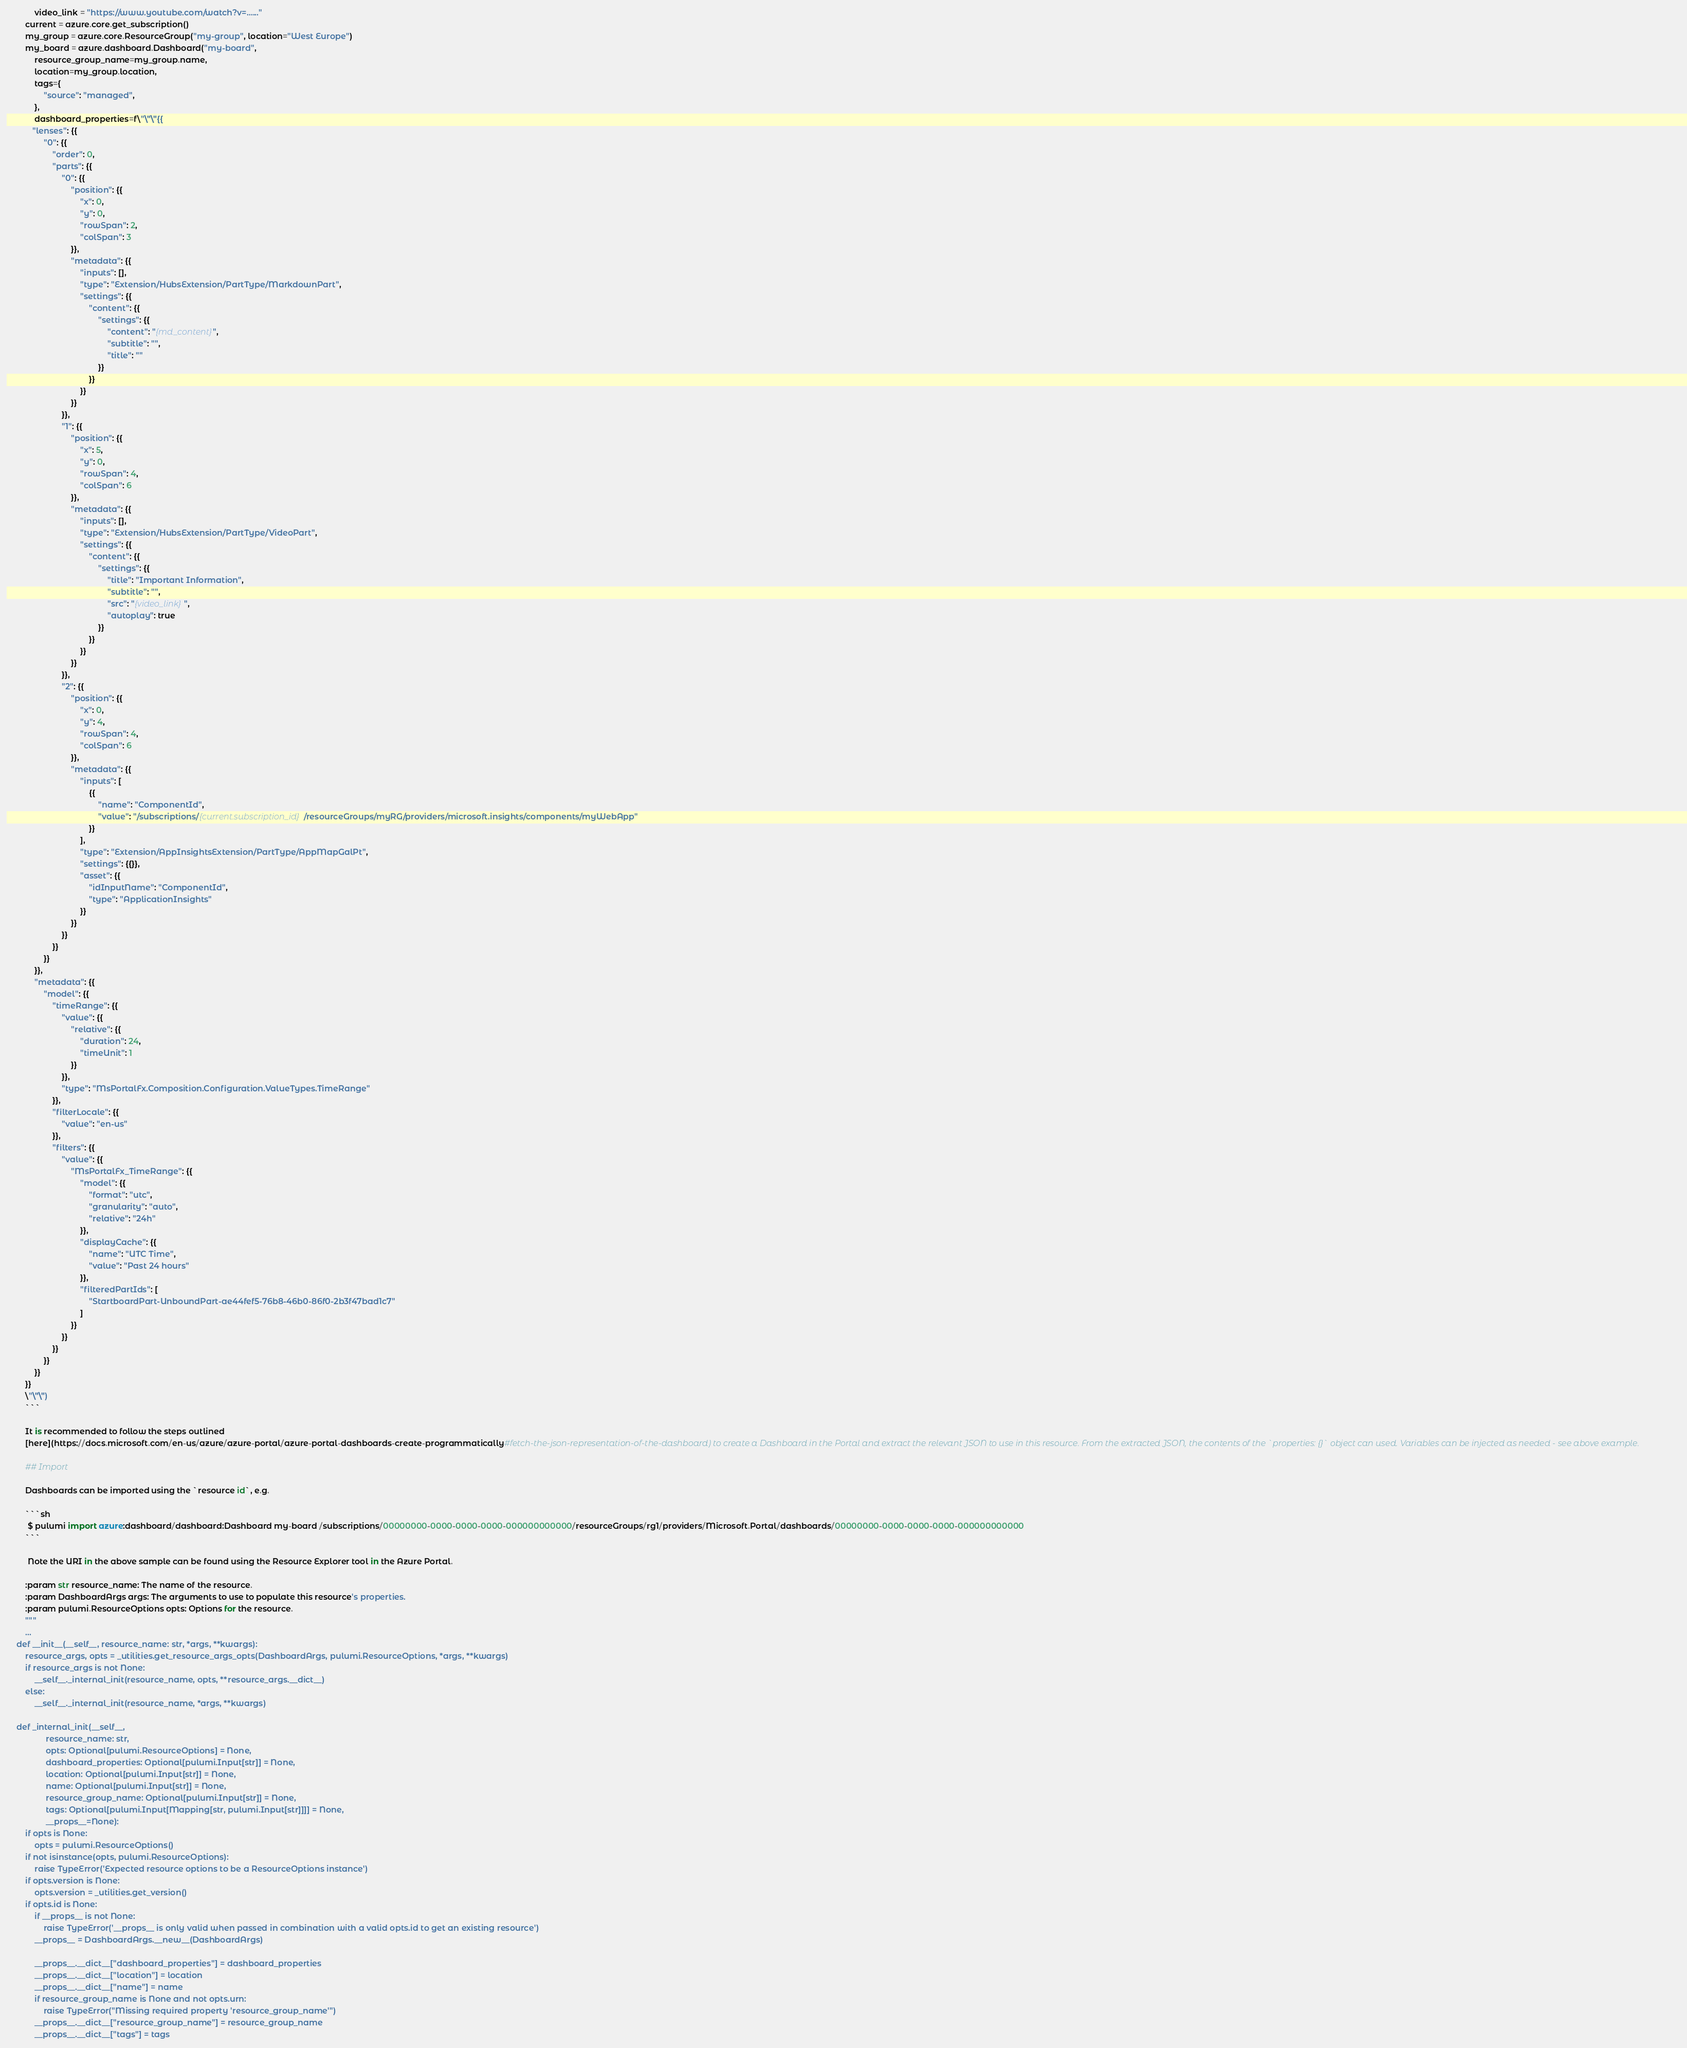Convert code to text. <code><loc_0><loc_0><loc_500><loc_500><_Python_>            video_link = "https://www.youtube.com/watch?v=......"
        current = azure.core.get_subscription()
        my_group = azure.core.ResourceGroup("my-group", location="West Europe")
        my_board = azure.dashboard.Dashboard("my-board",
            resource_group_name=my_group.name,
            location=my_group.location,
            tags={
                "source": "managed",
            },
            dashboard_properties=f\"\"\"{{
           "lenses": {{
                "0": {{
                    "order": 0,
                    "parts": {{
                        "0": {{
                            "position": {{
                                "x": 0,
                                "y": 0,
                                "rowSpan": 2,
                                "colSpan": 3
                            }},
                            "metadata": {{
                                "inputs": [],
                                "type": "Extension/HubsExtension/PartType/MarkdownPart",
                                "settings": {{
                                    "content": {{
                                        "settings": {{
                                            "content": "{md_content}",
                                            "subtitle": "",
                                            "title": ""
                                        }}
                                    }}
                                }}
                            }}
                        }},               
                        "1": {{
                            "position": {{
                                "x": 5,
                                "y": 0,
                                "rowSpan": 4,
                                "colSpan": 6
                            }},
                            "metadata": {{
                                "inputs": [],
                                "type": "Extension/HubsExtension/PartType/VideoPart",
                                "settings": {{
                                    "content": {{
                                        "settings": {{
                                            "title": "Important Information",
                                            "subtitle": "",
                                            "src": "{video_link}",
                                            "autoplay": true
                                        }}
                                    }}
                                }}
                            }}
                        }},
                        "2": {{
                            "position": {{
                                "x": 0,
                                "y": 4,
                                "rowSpan": 4,
                                "colSpan": 6
                            }},
                            "metadata": {{
                                "inputs": [
                                    {{
                                        "name": "ComponentId",
                                        "value": "/subscriptions/{current.subscription_id}/resourceGroups/myRG/providers/microsoft.insights/components/myWebApp"
                                    }}
                                ],
                                "type": "Extension/AppInsightsExtension/PartType/AppMapGalPt",
                                "settings": {{}},
                                "asset": {{
                                    "idInputName": "ComponentId",
                                    "type": "ApplicationInsights"
                                }}
                            }}
                        }}              
                    }}
                }}
            }},
            "metadata": {{
                "model": {{
                    "timeRange": {{
                        "value": {{
                            "relative": {{
                                "duration": 24,
                                "timeUnit": 1
                            }}
                        }},
                        "type": "MsPortalFx.Composition.Configuration.ValueTypes.TimeRange"
                    }},
                    "filterLocale": {{
                        "value": "en-us"
                    }},
                    "filters": {{
                        "value": {{
                            "MsPortalFx_TimeRange": {{
                                "model": {{
                                    "format": "utc",
                                    "granularity": "auto",
                                    "relative": "24h"
                                }},
                                "displayCache": {{
                                    "name": "UTC Time",
                                    "value": "Past 24 hours"
                                }},
                                "filteredPartIds": [
                                    "StartboardPart-UnboundPart-ae44fef5-76b8-46b0-86f0-2b3f47bad1c7"
                                ]
                            }}
                        }}
                    }}
                }}
            }}
        }}
        \"\"\")
        ```

        It is recommended to follow the steps outlined
        [here](https://docs.microsoft.com/en-us/azure/azure-portal/azure-portal-dashboards-create-programmatically#fetch-the-json-representation-of-the-dashboard) to create a Dashboard in the Portal and extract the relevant JSON to use in this resource. From the extracted JSON, the contents of the `properties: {}` object can used. Variables can be injected as needed - see above example.

        ## Import

        Dashboards can be imported using the `resource id`, e.g.

        ```sh
         $ pulumi import azure:dashboard/dashboard:Dashboard my-board /subscriptions/00000000-0000-0000-0000-000000000000/resourceGroups/rg1/providers/Microsoft.Portal/dashboards/00000000-0000-0000-0000-000000000000
        ```

         Note the URI in the above sample can be found using the Resource Explorer tool in the Azure Portal.

        :param str resource_name: The name of the resource.
        :param DashboardArgs args: The arguments to use to populate this resource's properties.
        :param pulumi.ResourceOptions opts: Options for the resource.
        """
        ...
    def __init__(__self__, resource_name: str, *args, **kwargs):
        resource_args, opts = _utilities.get_resource_args_opts(DashboardArgs, pulumi.ResourceOptions, *args, **kwargs)
        if resource_args is not None:
            __self__._internal_init(resource_name, opts, **resource_args.__dict__)
        else:
            __self__._internal_init(resource_name, *args, **kwargs)

    def _internal_init(__self__,
                 resource_name: str,
                 opts: Optional[pulumi.ResourceOptions] = None,
                 dashboard_properties: Optional[pulumi.Input[str]] = None,
                 location: Optional[pulumi.Input[str]] = None,
                 name: Optional[pulumi.Input[str]] = None,
                 resource_group_name: Optional[pulumi.Input[str]] = None,
                 tags: Optional[pulumi.Input[Mapping[str, pulumi.Input[str]]]] = None,
                 __props__=None):
        if opts is None:
            opts = pulumi.ResourceOptions()
        if not isinstance(opts, pulumi.ResourceOptions):
            raise TypeError('Expected resource options to be a ResourceOptions instance')
        if opts.version is None:
            opts.version = _utilities.get_version()
        if opts.id is None:
            if __props__ is not None:
                raise TypeError('__props__ is only valid when passed in combination with a valid opts.id to get an existing resource')
            __props__ = DashboardArgs.__new__(DashboardArgs)

            __props__.__dict__["dashboard_properties"] = dashboard_properties
            __props__.__dict__["location"] = location
            __props__.__dict__["name"] = name
            if resource_group_name is None and not opts.urn:
                raise TypeError("Missing required property 'resource_group_name'")
            __props__.__dict__["resource_group_name"] = resource_group_name
            __props__.__dict__["tags"] = tags</code> 